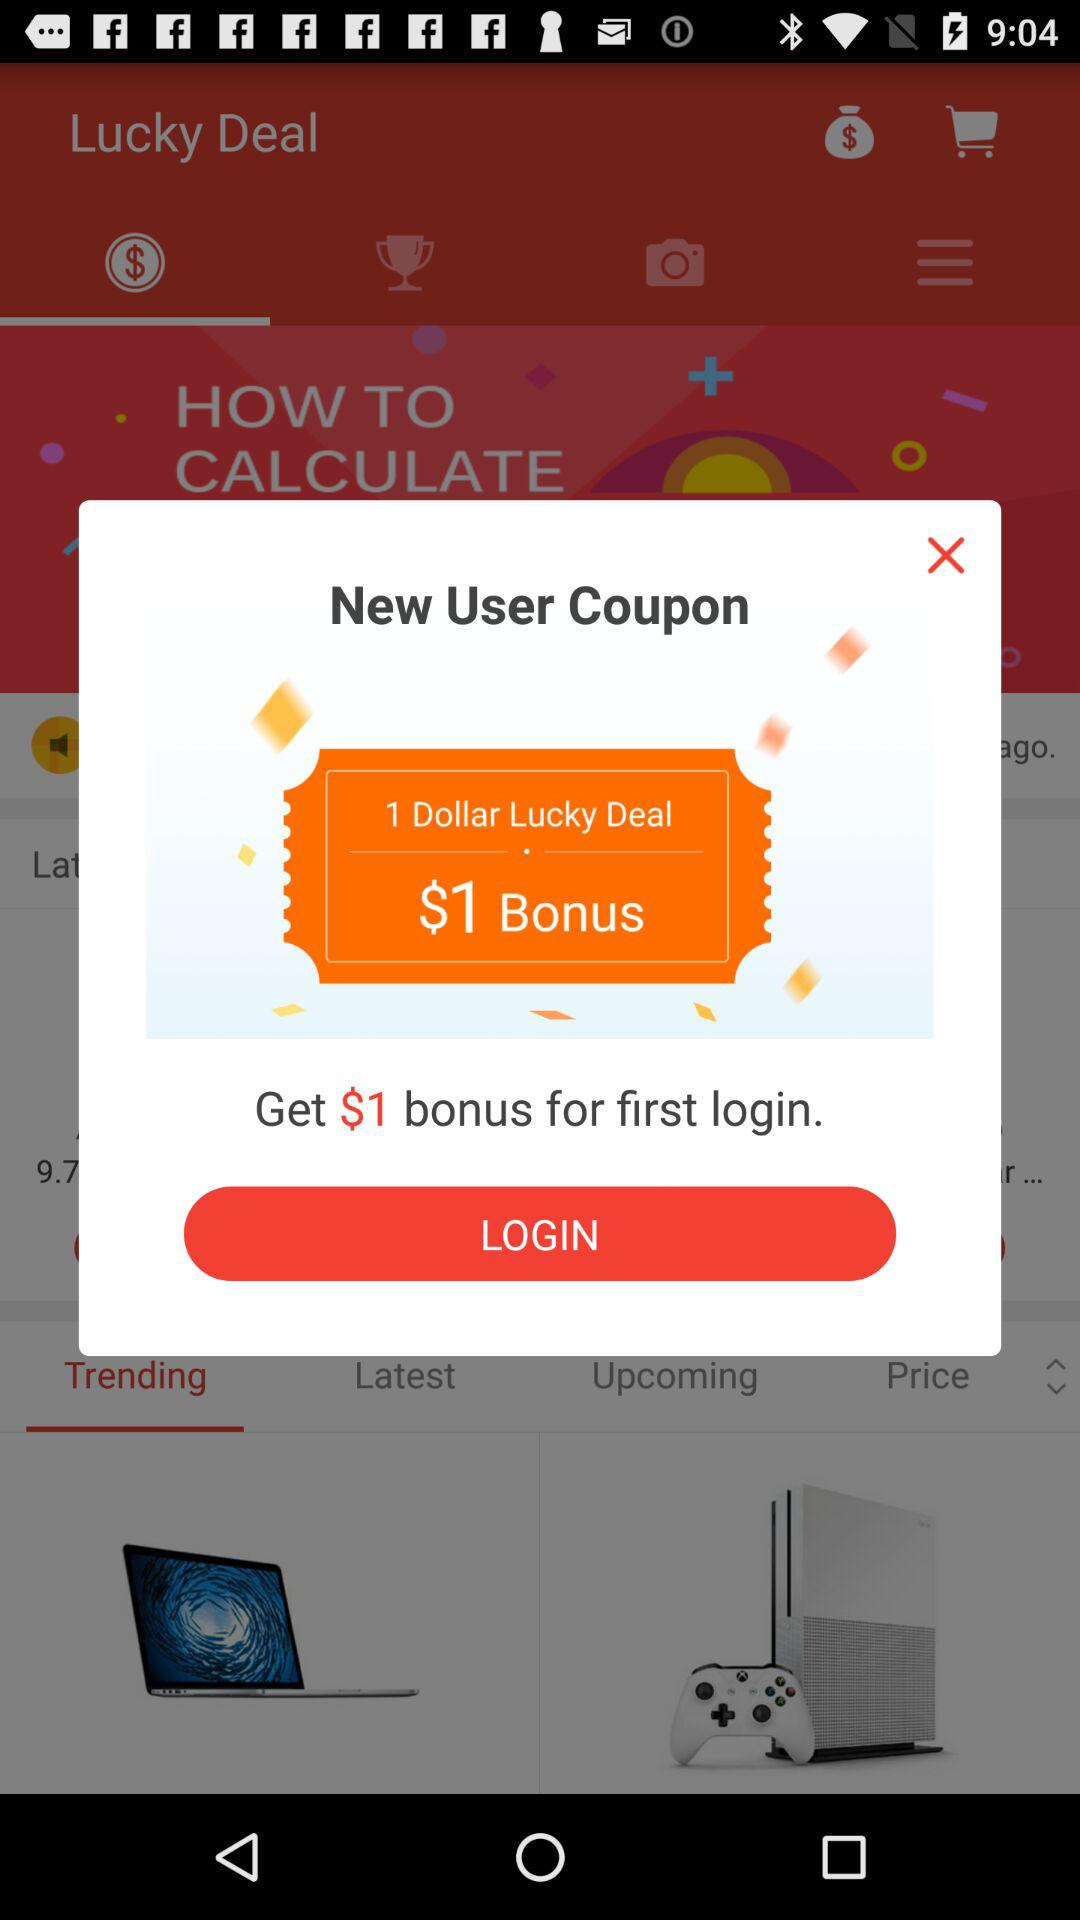How much is the bonus for the first login? The bonus for the first login is $1. 